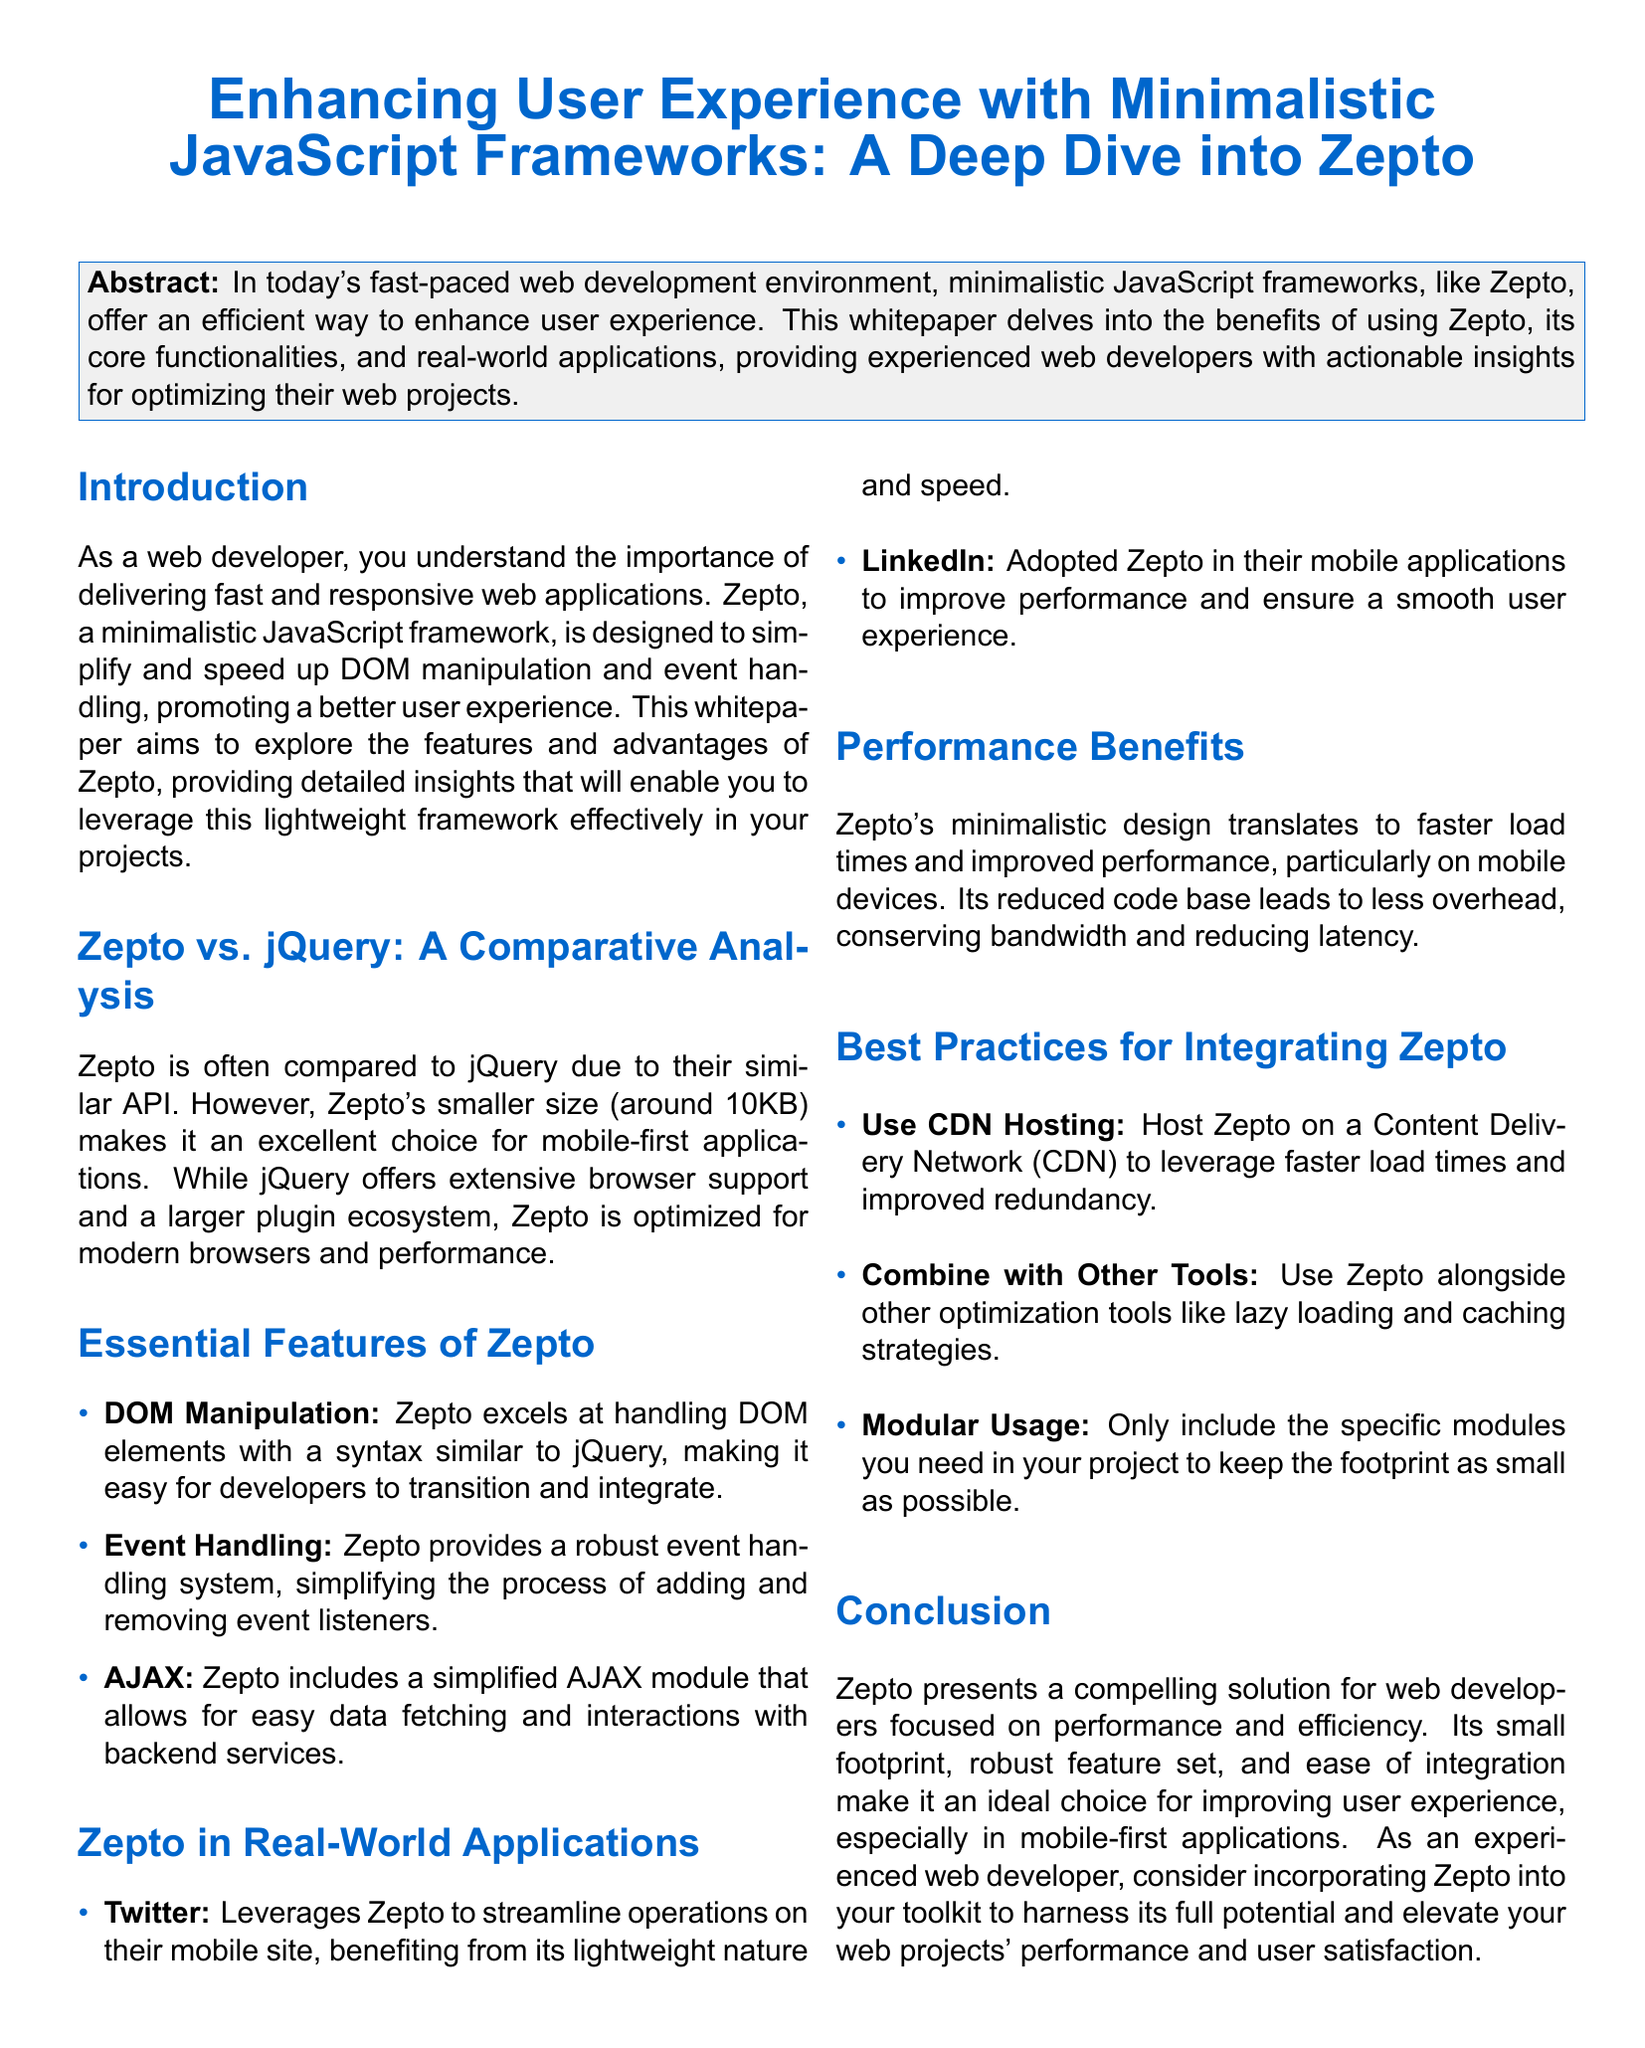What is the title of the document? The title of the document is stated in the header of the whitepaper.
Answer: Enhancing User Experience with Minimalistic JavaScript Frameworks: A Deep Dive into Zepto What is Zepto primarily compared to? The document specifically mentions a comparison that is a key focus of its analysis.
Answer: jQuery What is the size of Zepto? The size of Zepto is mentioned in the comparative analysis section of the document.
Answer: around 10KB Which company uses Zepto for their mobile site? The information about real-world applications of Zepto includes companies that utilize the framework.
Answer: Twitter What is a benefit of using Zepto mentioned in the document? The document highlights various advantages of utilizing Zepto within web development.
Answer: faster load times What is one of the best practices for integrating Zepto? The document provides specific recommendations for effectively using Zepto in projects.
Answer: Use CDN Hosting What kind of applications is Zepto optimized for? The advantages discussed in the document point to specific types of platforms where Zepto performs well.
Answer: mobile-first applications Which feature of Zepto allows for easy data fetching? The document elaborates on essential features, pinpointing specific capabilities of Zepto.
Answer: AJAX How does Zepto's design impact performance? The document discusses the implications of Zepto's design on web performance in detail.
Answer: reduced overhead 